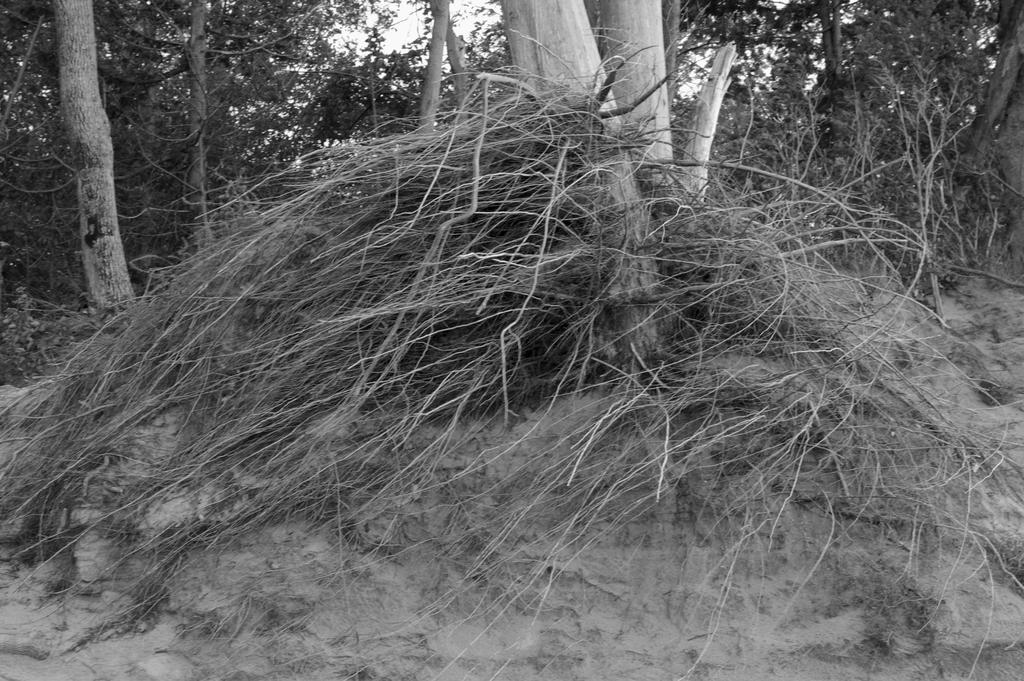What is the color scheme of the image? The image is black and white. What type of natural elements can be seen in the image? There are trees and branches visible in the image. What part of the natural environment is visible in the image? The sky is visible in the image. How many spiders can be seen on the church in the image? There is no church or spiders present in the image; it features trees and branches in a black and white color scheme. 